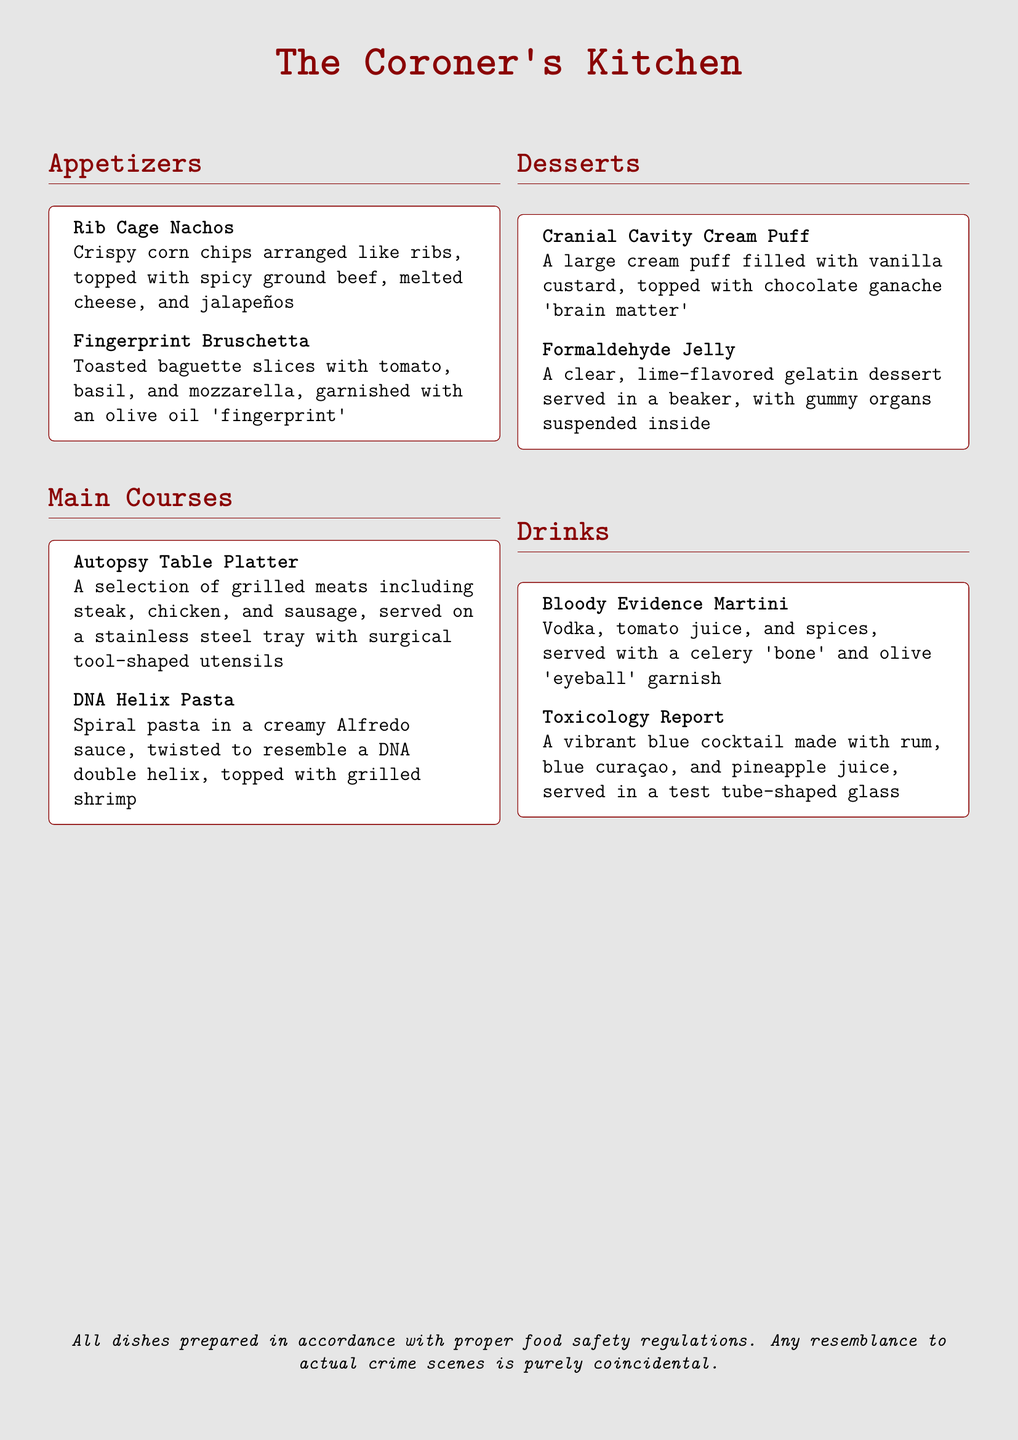What is the name of the first appetizer? The first appetizer listed is "Rib Cage Nachos."
Answer: Rib Cage Nachos How many main courses are included in the menu? There are two main courses mentioned in the document.
Answer: 2 What drink is garnished with a 'bone'? The drink that includes a 'bone' garnish is the "Bloody Evidence Martini."
Answer: Bloody Evidence Martini What dessert resembles a brain? The dessert that resembles a brain is the "Cranial Cavity Cream Puff."
Answer: Cranial Cavity Cream Puff What type of glass is the "Toxicology Report" served in? The drink "Toxicology Report" is served in a test tube-shaped glass.
Answer: test tube-shaped glass What is the main ingredient in the "Formaldehyde Jelly"? The main ingredient in "Formaldehyde Jelly" is lime-flavored gelatin.
Answer: lime-flavored gelatin What kind of utensil is used for the "Autopsy Table Platter"? Surgical tool-shaped utensils are used for the "Autopsy Table Platter."
Answer: Surgical tool-shaped utensils How does the "DNA Helix Pasta" look like? The "DNA Helix Pasta" is twisted to resemble a DNA double helix.
Answer: DNA double helix What flavor is the "Formaldehyde Jelly"? The flavor of "Formaldehyde Jelly" is lime.
Answer: lime 